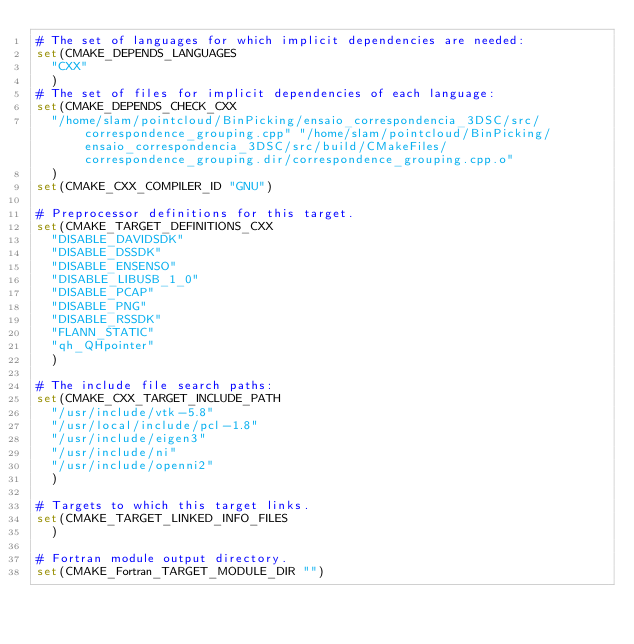Convert code to text. <code><loc_0><loc_0><loc_500><loc_500><_CMake_># The set of languages for which implicit dependencies are needed:
set(CMAKE_DEPENDS_LANGUAGES
  "CXX"
  )
# The set of files for implicit dependencies of each language:
set(CMAKE_DEPENDS_CHECK_CXX
  "/home/slam/pointcloud/BinPicking/ensaio_correspondencia_3DSC/src/correspondence_grouping.cpp" "/home/slam/pointcloud/BinPicking/ensaio_correspondencia_3DSC/src/build/CMakeFiles/correspondence_grouping.dir/correspondence_grouping.cpp.o"
  )
set(CMAKE_CXX_COMPILER_ID "GNU")

# Preprocessor definitions for this target.
set(CMAKE_TARGET_DEFINITIONS_CXX
  "DISABLE_DAVIDSDK"
  "DISABLE_DSSDK"
  "DISABLE_ENSENSO"
  "DISABLE_LIBUSB_1_0"
  "DISABLE_PCAP"
  "DISABLE_PNG"
  "DISABLE_RSSDK"
  "FLANN_STATIC"
  "qh_QHpointer"
  )

# The include file search paths:
set(CMAKE_CXX_TARGET_INCLUDE_PATH
  "/usr/include/vtk-5.8"
  "/usr/local/include/pcl-1.8"
  "/usr/include/eigen3"
  "/usr/include/ni"
  "/usr/include/openni2"
  )

# Targets to which this target links.
set(CMAKE_TARGET_LINKED_INFO_FILES
  )

# Fortran module output directory.
set(CMAKE_Fortran_TARGET_MODULE_DIR "")
</code> 